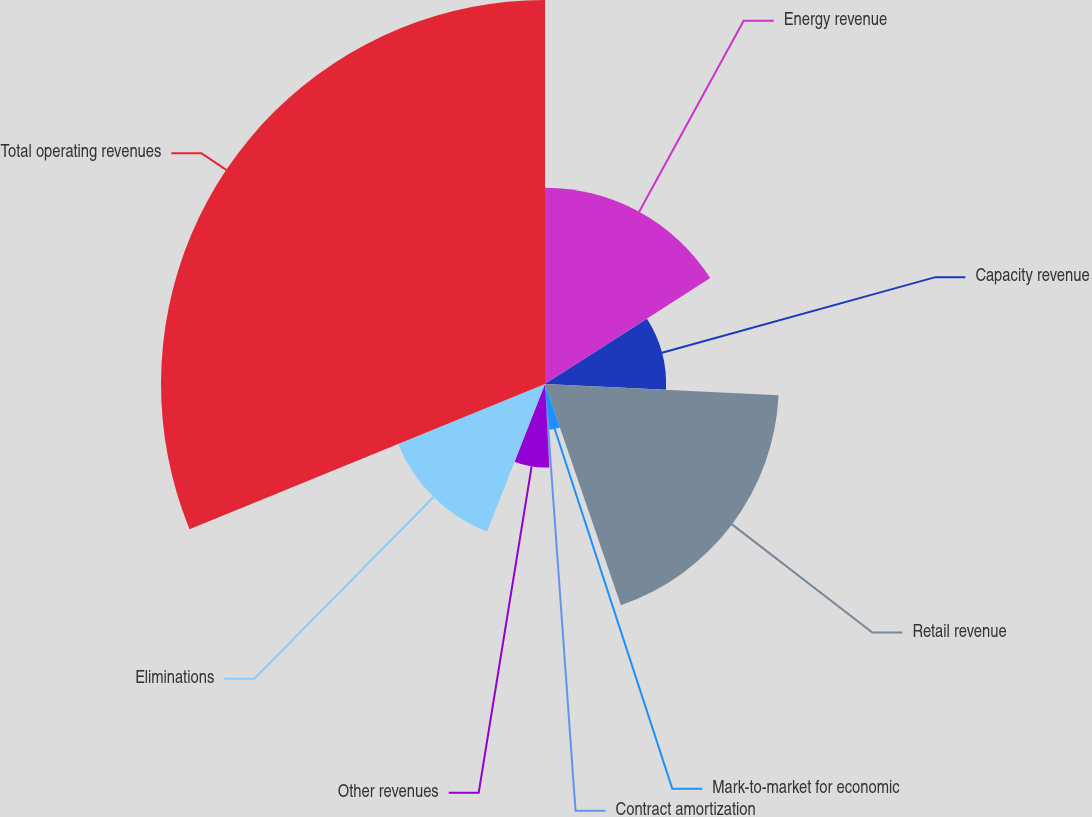<chart> <loc_0><loc_0><loc_500><loc_500><pie_chart><fcel>Energy revenue<fcel>Capacity revenue<fcel>Retail revenue<fcel>Mark-to-market for economic<fcel>Contract amortization<fcel>Other revenues<fcel>Eliminations<fcel>Total operating revenues<nl><fcel>15.93%<fcel>9.83%<fcel>18.98%<fcel>3.74%<fcel>0.69%<fcel>6.78%<fcel>12.88%<fcel>31.17%<nl></chart> 